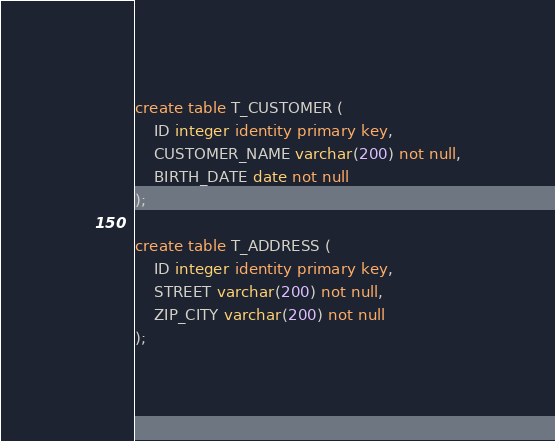Convert code to text. <code><loc_0><loc_0><loc_500><loc_500><_SQL_>create table T_CUSTOMER (
    ID integer identity primary key, 
    CUSTOMER_NAME varchar(200) not null,
    BIRTH_DATE date not null
);

create table T_ADDRESS (
    ID integer identity primary key, 
    STREET varchar(200) not null,
    ZIP_CITY varchar(200) not null
);</code> 